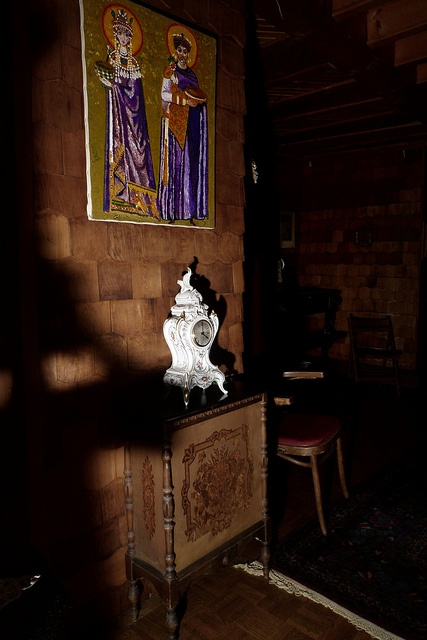Describe the objects in this image and their specific colors. I can see chair in black, maroon, and gray tones, chair in black tones, and clock in black, gray, and darkgray tones in this image. 